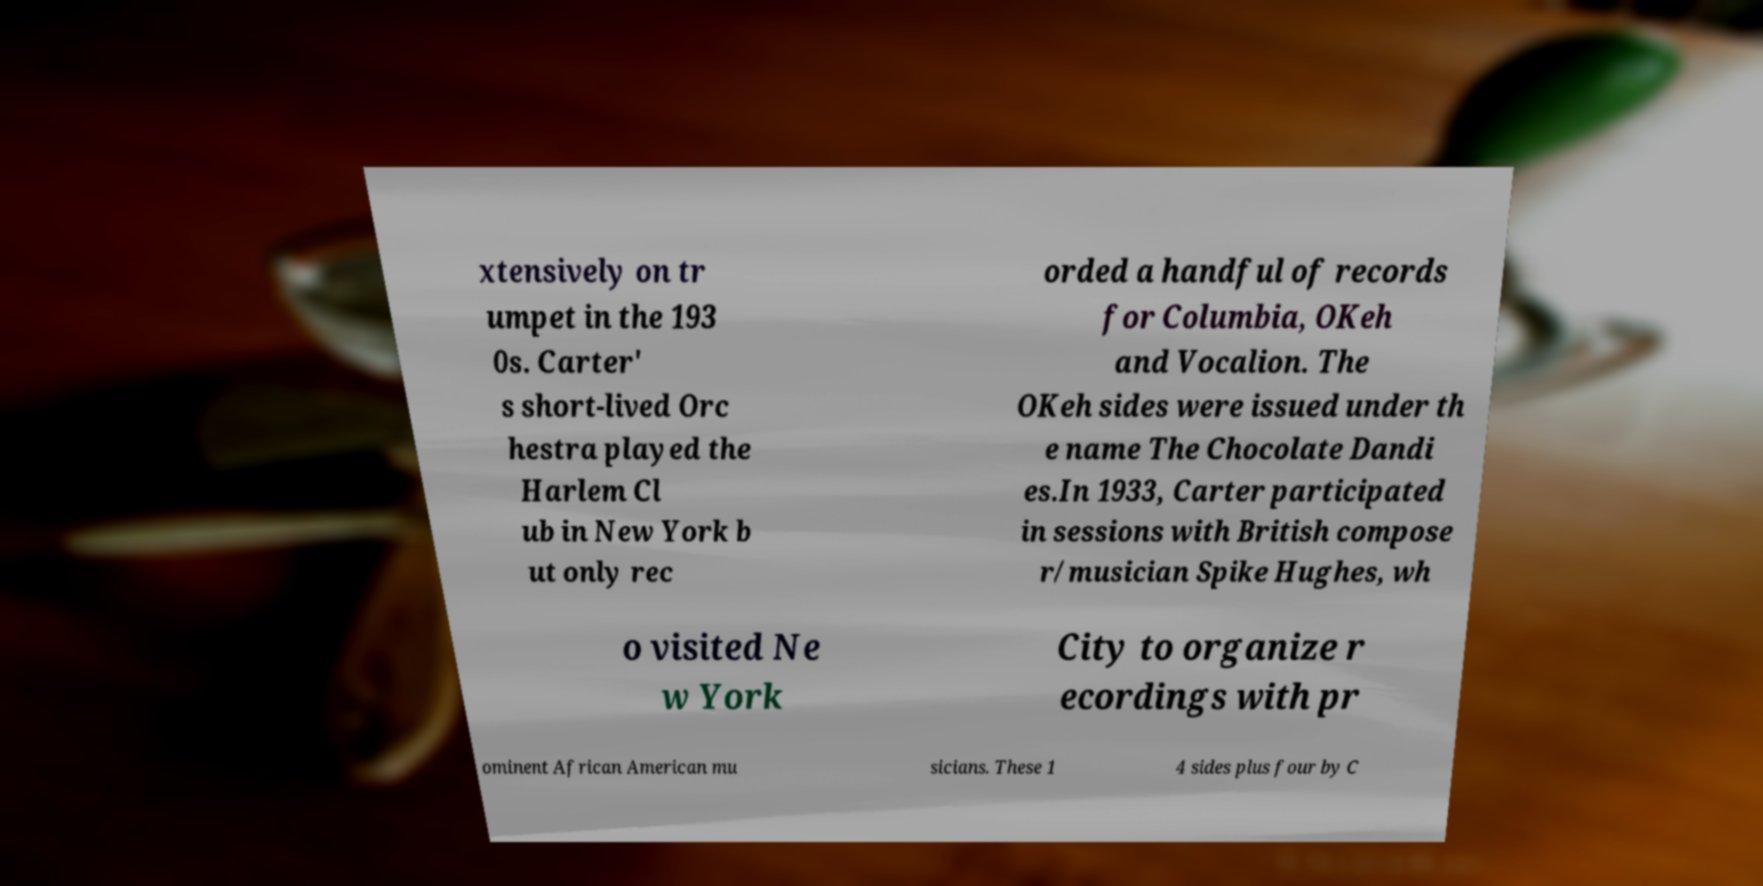I need the written content from this picture converted into text. Can you do that? xtensively on tr umpet in the 193 0s. Carter' s short-lived Orc hestra played the Harlem Cl ub in New York b ut only rec orded a handful of records for Columbia, OKeh and Vocalion. The OKeh sides were issued under th e name The Chocolate Dandi es.In 1933, Carter participated in sessions with British compose r/musician Spike Hughes, wh o visited Ne w York City to organize r ecordings with pr ominent African American mu sicians. These 1 4 sides plus four by C 